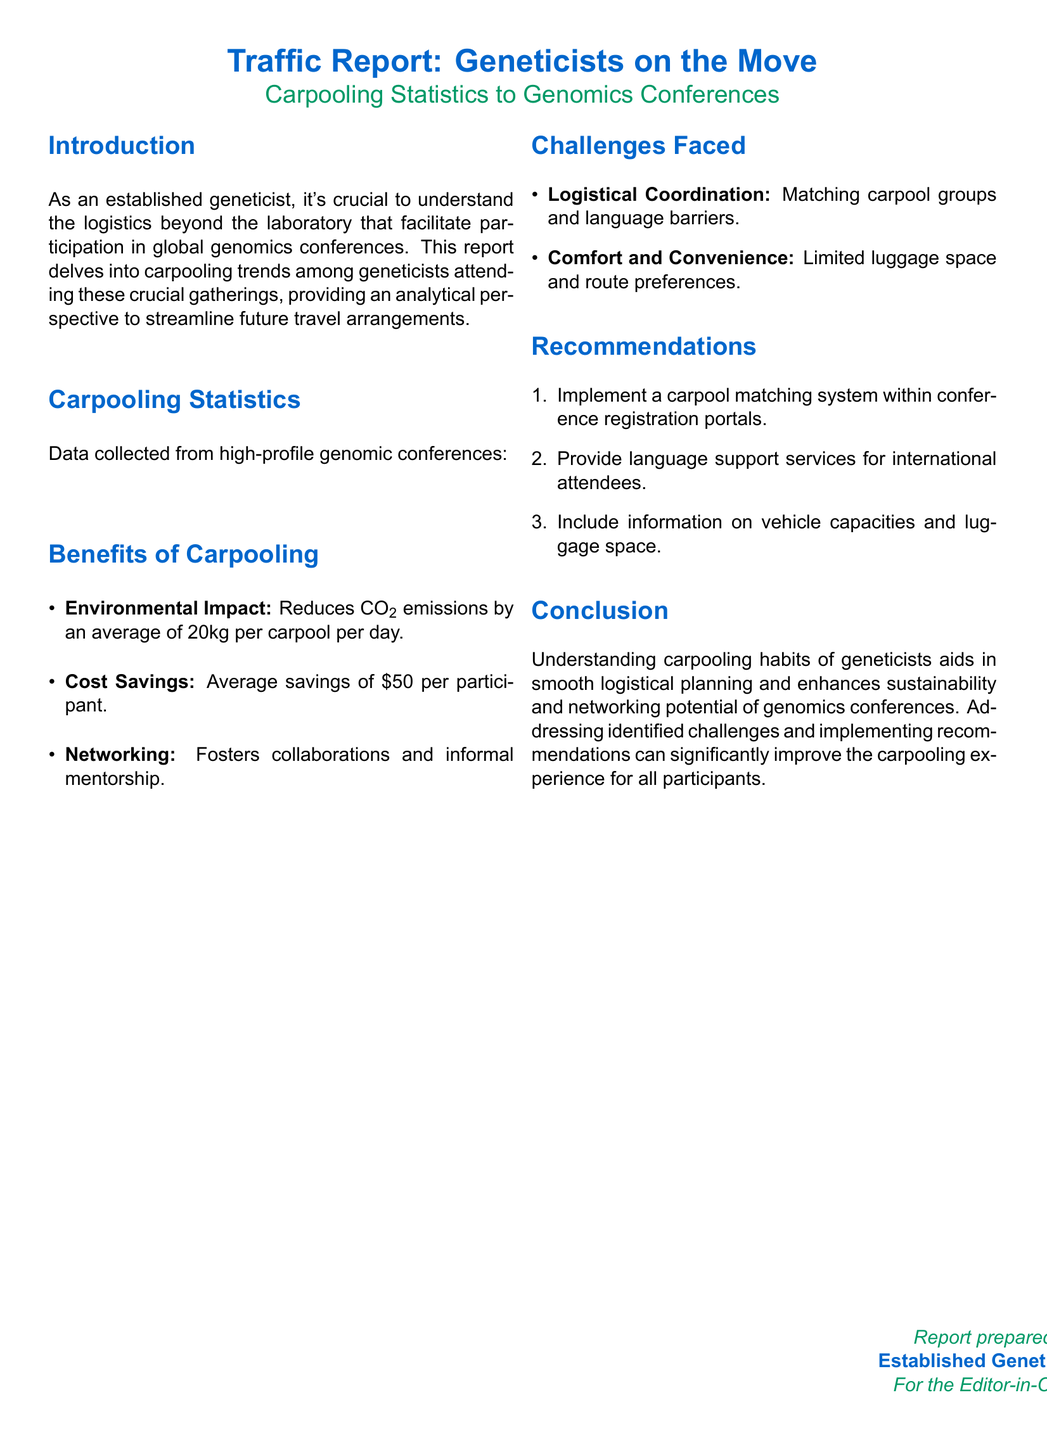What is the title of the report? The title of the report is indicated at the top of the document.
Answer: Traffic Report: Geneticists on the Move How many carpoolers attended the ASHG Annual Meeting? The number of carpoolers is shown in the Carpooling Statistics table.
Answer: 150 What percentage of attendees at the ESHG Conference used carpooling? The percentage of carpoolers is also listed in the Carpooling Statistics table.
Answer: 6.67% Name one benefit of carpooling mentioned in the report. Benefits of carpooling are listed in the corresponding section of the document.
Answer: Environmental Impact What is one challenge faced in carpooling? Challenges are outlined in the relevant section, making it easy to identify one.
Answer: Logistical Coordination What is a recommendation given for improving carpooling? Recommendations are presented in a numbered list format, indicating actionable steps.
Answer: Implement a carpool matching system How much does carpooling save on average per participant? The cost savings are mentioned under the Benefits of Carpooling heading.
Answer: $50 Which event had the least number of carpoolers? The Carpooling Statistics table provides data to compare the number of carpoolers across events.
Answer: ICG What is the average CO2 emission reduction per carpool per day? The environmental impact of carpooling is detailed in the Benefits section.
Answer: 20kg 